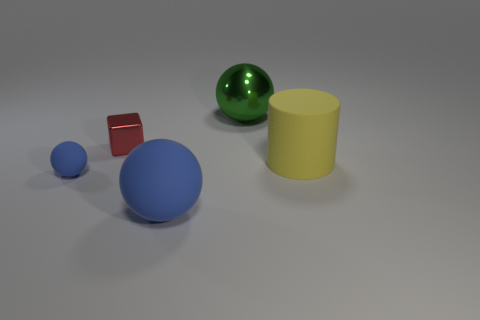Subtract all purple blocks. How many blue spheres are left? 2 Subtract all large matte spheres. How many spheres are left? 2 Add 3 large red metallic objects. How many objects exist? 8 Subtract all cylinders. How many objects are left? 4 Subtract all tiny red metallic cubes. Subtract all big blue spheres. How many objects are left? 3 Add 5 green shiny balls. How many green shiny balls are left? 6 Add 1 blue spheres. How many blue spheres exist? 3 Subtract 0 yellow spheres. How many objects are left? 5 Subtract all yellow balls. Subtract all yellow cylinders. How many balls are left? 3 